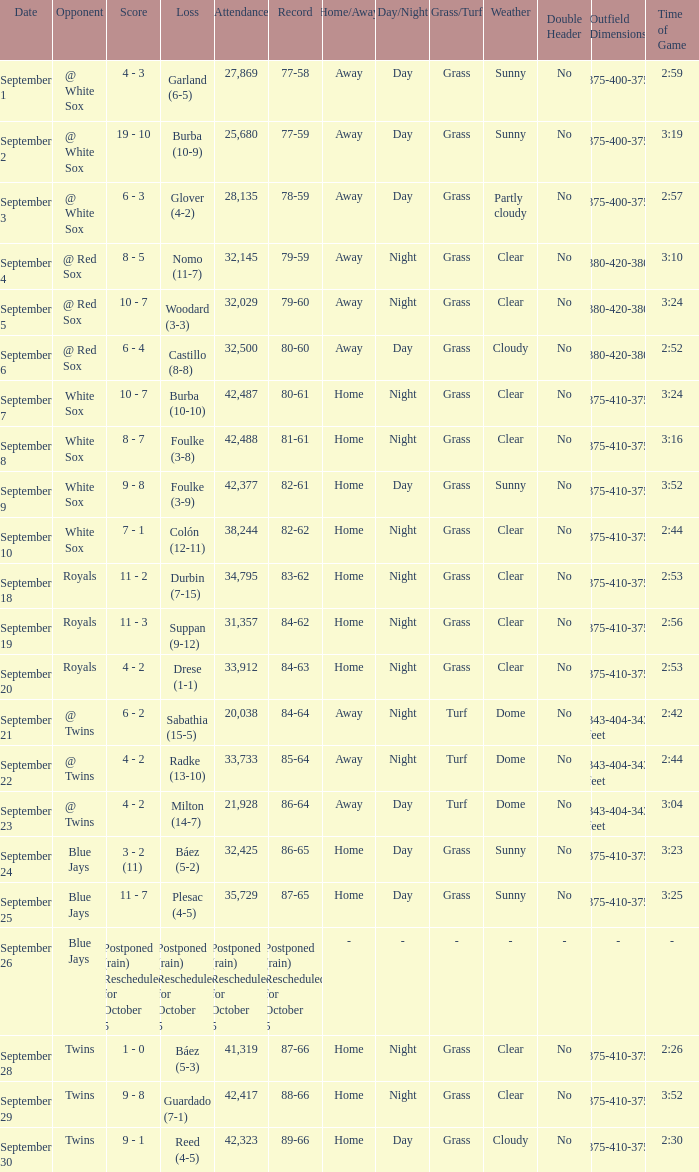What is the score of the game that holds a record of 80-61? 10 - 7. Give me the full table as a dictionary. {'header': ['Date', 'Opponent', 'Score', 'Loss', 'Attendance', 'Record', 'Home/Away', 'Day/Night', 'Grass/Turf', 'Weather', 'Double Header', 'Outfield Dimensions', 'Time of Game'], 'rows': [['September 1', '@ White Sox', '4 - 3', 'Garland (6-5)', '27,869', '77-58', 'Away', 'Day', 'Grass', 'Sunny', 'No', '330-375-400-375-330 feet', '2:59'], ['September 2', '@ White Sox', '19 - 10', 'Burba (10-9)', '25,680', '77-59', 'Away', 'Day', 'Grass', 'Sunny', 'No', '330-375-400-375-330 feet', '3:19'], ['September 3', '@ White Sox', '6 - 3', 'Glover (4-2)', '28,135', '78-59', 'Away', 'Day', 'Grass', 'Partly cloudy', 'No', '330-375-400-375-330 feet', '2:57'], ['September 4', '@ Red Sox', '8 - 5', 'Nomo (11-7)', '32,145', '79-59', 'Away', 'Night', 'Grass', 'Clear', 'No', '310-380-420-380-310 feet', '3:10'], ['September 5', '@ Red Sox', '10 - 7', 'Woodard (3-3)', '32,029', '79-60', 'Away', 'Night', 'Grass', 'Clear', 'No', '310-380-420-380-310 feet', '3:24'], ['September 6', '@ Red Sox', '6 - 4', 'Castillo (8-8)', '32,500', '80-60', 'Away', 'Day', 'Grass', 'Cloudy', 'No', '310-380-420-380-310 feet', '2:52'], ['September 7', 'White Sox', '10 - 7', 'Burba (10-10)', '42,487', '80-61', 'Home', 'Night', 'Grass', 'Clear', 'No', '325-375-410-375-325 feet', '3:24'], ['September 8', 'White Sox', '8 - 7', 'Foulke (3-8)', '42,488', '81-61', 'Home', 'Night', 'Grass', 'Clear', 'No', '325-375-410-375-325 feet', '3:16'], ['September 9', 'White Sox', '9 - 8', 'Foulke (3-9)', '42,377', '82-61', 'Home', 'Day', 'Grass', 'Sunny', 'No', '325-375-410-375-325 feet', '3:52'], ['September 10', 'White Sox', '7 - 1', 'Colón (12-11)', '38,244', '82-62', 'Home', 'Night', 'Grass', 'Clear', 'No', '325-375-410-375-325 feet', '2:44'], ['September 18', 'Royals', '11 - 2', 'Durbin (7-15)', '34,795', '83-62', 'Home', 'Night', 'Grass', 'Clear', 'No', '325-375-410-375-325 feet', '2:53'], ['September 19', 'Royals', '11 - 3', 'Suppan (9-12)', '31,357', '84-62', 'Home', 'Night', 'Grass', 'Clear', 'No', '325-375-410-375-325 feet', '2:56'], ['September 20', 'Royals', '4 - 2', 'Drese (1-1)', '33,912', '84-63', 'Home', 'Night', 'Grass', 'Clear', 'No', '325-375-410-375-325 feet', '2:53'], ['September 21', '@ Twins', '6 - 2', 'Sabathia (15-5)', '20,038', '84-64', 'Away', 'Night', 'Turf', 'Dome', 'No', '343-404-343 feet', '2:42'], ['September 22', '@ Twins', '4 - 2', 'Radke (13-10)', '33,733', '85-64', 'Away', 'Night', 'Turf', 'Dome', 'No', '343-404-343 feet', '2:44'], ['September 23', '@ Twins', '4 - 2', 'Milton (14-7)', '21,928', '86-64', 'Away', 'Day', 'Turf', 'Dome', 'No', '343-404-343 feet', '3:04'], ['September 24', 'Blue Jays', '3 - 2 (11)', 'Báez (5-2)', '32,425', '86-65', 'Home', 'Day', 'Grass', 'Sunny', 'No', '325-375-410-375-325 feet', '3:23'], ['September 25', 'Blue Jays', '11 - 7', 'Plesac (4-5)', '35,729', '87-65', 'Home', 'Day', 'Grass', 'Sunny', 'No', '325-375-410-375-325 feet', '3:25'], ['September 26', 'Blue Jays', 'Postponed (rain) Rescheduled for October 5', 'Postponed (rain) Rescheduled for October 5', 'Postponed (rain) Rescheduled for October 5', 'Postponed (rain) Rescheduled for October 5', '-', '-', '-', '-', '-', '-', '-'], ['September 28', 'Twins', '1 - 0', 'Báez (5-3)', '41,319', '87-66', 'Home', 'Night', 'Grass', 'Clear', 'No', '325-375-410-375-325 feet', '2:26'], ['September 29', 'Twins', '9 - 8', 'Guardado (7-1)', '42,417', '88-66', 'Home', 'Night', 'Grass', 'Clear', 'No', '325-375-410-375-325 feet', '3:52'], ['September 30', 'Twins', '9 - 1', 'Reed (4-5)', '42,323', '89-66', 'Home', 'Day', 'Grass', 'Cloudy', 'No', '325-375-410-375-325 feet', '2:30']]} 